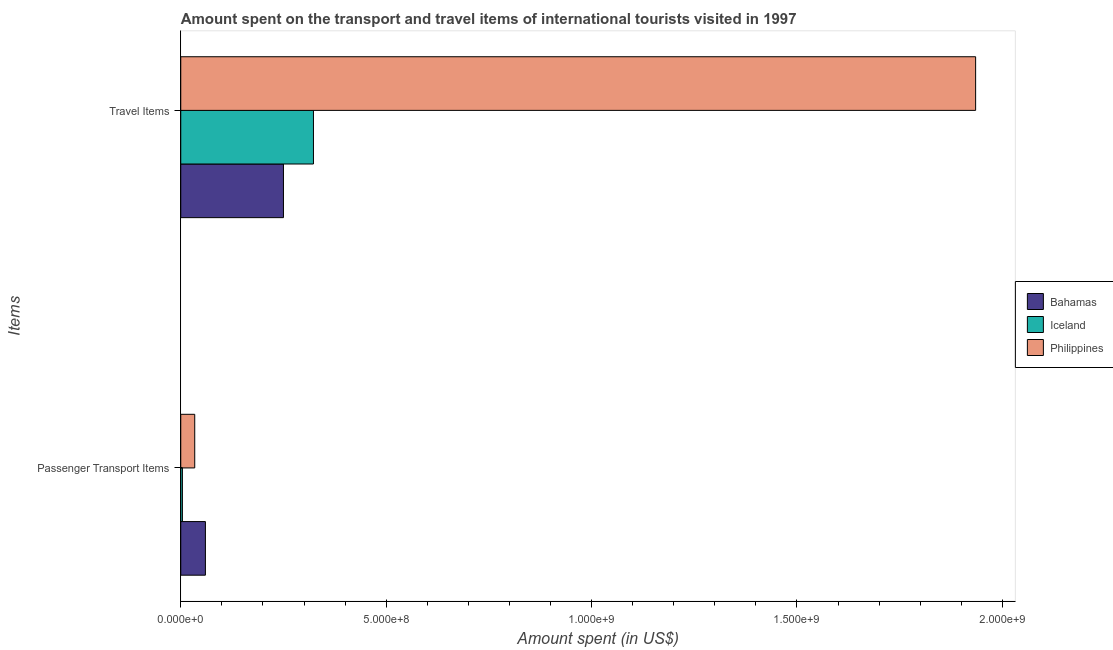How many groups of bars are there?
Provide a succinct answer. 2. Are the number of bars per tick equal to the number of legend labels?
Your answer should be very brief. Yes. Are the number of bars on each tick of the Y-axis equal?
Offer a terse response. Yes. What is the label of the 2nd group of bars from the top?
Keep it short and to the point. Passenger Transport Items. What is the amount spent in travel items in Philippines?
Make the answer very short. 1.94e+09. Across all countries, what is the maximum amount spent on passenger transport items?
Keep it short and to the point. 6.00e+07. Across all countries, what is the minimum amount spent in travel items?
Your response must be concise. 2.50e+08. In which country was the amount spent on passenger transport items maximum?
Provide a succinct answer. Bahamas. In which country was the amount spent on passenger transport items minimum?
Provide a succinct answer. Iceland. What is the total amount spent in travel items in the graph?
Provide a succinct answer. 2.51e+09. What is the difference between the amount spent in travel items in Bahamas and that in Philippines?
Your answer should be compact. -1.68e+09. What is the difference between the amount spent in travel items in Iceland and the amount spent on passenger transport items in Bahamas?
Provide a short and direct response. 2.63e+08. What is the average amount spent on passenger transport items per country?
Your answer should be very brief. 3.27e+07. What is the difference between the amount spent in travel items and amount spent on passenger transport items in Philippines?
Your answer should be very brief. 1.90e+09. In how many countries, is the amount spent on passenger transport items greater than 1100000000 US$?
Your response must be concise. 0. What is the ratio of the amount spent on passenger transport items in Bahamas to that in Philippines?
Offer a terse response. 1.76. In how many countries, is the amount spent in travel items greater than the average amount spent in travel items taken over all countries?
Offer a terse response. 1. What does the 3rd bar from the top in Travel Items represents?
Your answer should be very brief. Bahamas. How many bars are there?
Ensure brevity in your answer.  6. How many countries are there in the graph?
Your answer should be very brief. 3. Does the graph contain any zero values?
Your answer should be compact. No. How many legend labels are there?
Your answer should be compact. 3. How are the legend labels stacked?
Provide a succinct answer. Vertical. What is the title of the graph?
Keep it short and to the point. Amount spent on the transport and travel items of international tourists visited in 1997. What is the label or title of the X-axis?
Give a very brief answer. Amount spent (in US$). What is the label or title of the Y-axis?
Offer a terse response. Items. What is the Amount spent (in US$) of Bahamas in Passenger Transport Items?
Make the answer very short. 6.00e+07. What is the Amount spent (in US$) of Philippines in Passenger Transport Items?
Offer a terse response. 3.40e+07. What is the Amount spent (in US$) of Bahamas in Travel Items?
Provide a succinct answer. 2.50e+08. What is the Amount spent (in US$) of Iceland in Travel Items?
Offer a very short reply. 3.23e+08. What is the Amount spent (in US$) of Philippines in Travel Items?
Make the answer very short. 1.94e+09. Across all Items, what is the maximum Amount spent (in US$) of Bahamas?
Give a very brief answer. 2.50e+08. Across all Items, what is the maximum Amount spent (in US$) in Iceland?
Your answer should be very brief. 3.23e+08. Across all Items, what is the maximum Amount spent (in US$) of Philippines?
Give a very brief answer. 1.94e+09. Across all Items, what is the minimum Amount spent (in US$) in Bahamas?
Offer a very short reply. 6.00e+07. Across all Items, what is the minimum Amount spent (in US$) of Philippines?
Give a very brief answer. 3.40e+07. What is the total Amount spent (in US$) in Bahamas in the graph?
Provide a succinct answer. 3.10e+08. What is the total Amount spent (in US$) in Iceland in the graph?
Provide a succinct answer. 3.27e+08. What is the total Amount spent (in US$) in Philippines in the graph?
Your answer should be very brief. 1.97e+09. What is the difference between the Amount spent (in US$) in Bahamas in Passenger Transport Items and that in Travel Items?
Make the answer very short. -1.90e+08. What is the difference between the Amount spent (in US$) in Iceland in Passenger Transport Items and that in Travel Items?
Make the answer very short. -3.19e+08. What is the difference between the Amount spent (in US$) of Philippines in Passenger Transport Items and that in Travel Items?
Make the answer very short. -1.90e+09. What is the difference between the Amount spent (in US$) in Bahamas in Passenger Transport Items and the Amount spent (in US$) in Iceland in Travel Items?
Your response must be concise. -2.63e+08. What is the difference between the Amount spent (in US$) in Bahamas in Passenger Transport Items and the Amount spent (in US$) in Philippines in Travel Items?
Provide a short and direct response. -1.88e+09. What is the difference between the Amount spent (in US$) of Iceland in Passenger Transport Items and the Amount spent (in US$) of Philippines in Travel Items?
Offer a very short reply. -1.93e+09. What is the average Amount spent (in US$) of Bahamas per Items?
Provide a succinct answer. 1.55e+08. What is the average Amount spent (in US$) in Iceland per Items?
Your response must be concise. 1.64e+08. What is the average Amount spent (in US$) of Philippines per Items?
Your answer should be compact. 9.84e+08. What is the difference between the Amount spent (in US$) of Bahamas and Amount spent (in US$) of Iceland in Passenger Transport Items?
Give a very brief answer. 5.60e+07. What is the difference between the Amount spent (in US$) of Bahamas and Amount spent (in US$) of Philippines in Passenger Transport Items?
Offer a very short reply. 2.60e+07. What is the difference between the Amount spent (in US$) in Iceland and Amount spent (in US$) in Philippines in Passenger Transport Items?
Provide a succinct answer. -3.00e+07. What is the difference between the Amount spent (in US$) in Bahamas and Amount spent (in US$) in Iceland in Travel Items?
Keep it short and to the point. -7.30e+07. What is the difference between the Amount spent (in US$) of Bahamas and Amount spent (in US$) of Philippines in Travel Items?
Offer a very short reply. -1.68e+09. What is the difference between the Amount spent (in US$) in Iceland and Amount spent (in US$) in Philippines in Travel Items?
Your response must be concise. -1.61e+09. What is the ratio of the Amount spent (in US$) in Bahamas in Passenger Transport Items to that in Travel Items?
Offer a terse response. 0.24. What is the ratio of the Amount spent (in US$) in Iceland in Passenger Transport Items to that in Travel Items?
Your response must be concise. 0.01. What is the ratio of the Amount spent (in US$) of Philippines in Passenger Transport Items to that in Travel Items?
Provide a succinct answer. 0.02. What is the difference between the highest and the second highest Amount spent (in US$) in Bahamas?
Ensure brevity in your answer.  1.90e+08. What is the difference between the highest and the second highest Amount spent (in US$) of Iceland?
Provide a short and direct response. 3.19e+08. What is the difference between the highest and the second highest Amount spent (in US$) in Philippines?
Offer a very short reply. 1.90e+09. What is the difference between the highest and the lowest Amount spent (in US$) in Bahamas?
Provide a succinct answer. 1.90e+08. What is the difference between the highest and the lowest Amount spent (in US$) of Iceland?
Provide a succinct answer. 3.19e+08. What is the difference between the highest and the lowest Amount spent (in US$) of Philippines?
Offer a terse response. 1.90e+09. 